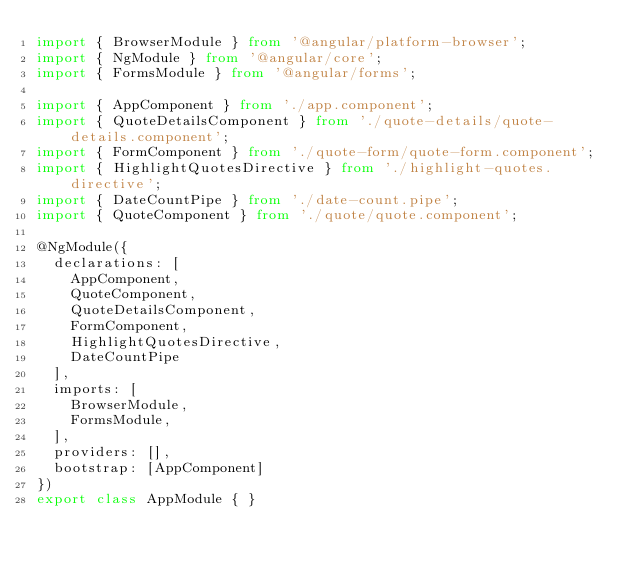Convert code to text. <code><loc_0><loc_0><loc_500><loc_500><_TypeScript_>import { BrowserModule } from '@angular/platform-browser';
import { NgModule } from '@angular/core';
import { FormsModule } from '@angular/forms';

import { AppComponent } from './app.component';
import { QuoteDetailsComponent } from './quote-details/quote-details.component';
import { FormComponent } from './quote-form/quote-form.component';
import { HighlightQuotesDirective } from './highlight-quotes.directive';
import { DateCountPipe } from './date-count.pipe';
import { QuoteComponent } from './quote/quote.component';

@NgModule({
  declarations: [
    AppComponent,
    QuoteComponent,
    QuoteDetailsComponent,
    FormComponent,
    HighlightQuotesDirective,
    DateCountPipe
  ],
  imports: [
    BrowserModule,
    FormsModule,
  ],
  providers: [],
  bootstrap: [AppComponent]
})
export class AppModule { }
</code> 